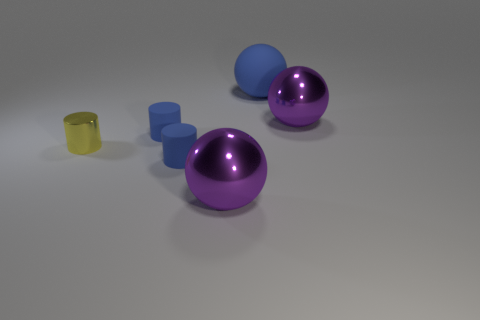Are there any tiny metal cylinders that are behind the large rubber ball to the right of the small thing in front of the tiny metallic object?
Ensure brevity in your answer.  No. The yellow object is what shape?
Ensure brevity in your answer.  Cylinder. Is the number of objects to the right of the metallic cylinder less than the number of shiny cylinders?
Provide a short and direct response. No. Is there a big purple metal thing that has the same shape as the tiny metallic thing?
Provide a succinct answer. No. What number of things are small metallic things or things?
Give a very brief answer. 6. Is there a big purple metallic object?
Provide a succinct answer. Yes. Is the number of objects less than the number of matte cylinders?
Give a very brief answer. No. Are there any gray matte spheres that have the same size as the yellow metallic cylinder?
Your answer should be very brief. No. There is a yellow metal object; does it have the same shape as the purple thing that is to the right of the big blue rubber object?
Provide a short and direct response. No. How many cylinders are either big matte objects or yellow shiny things?
Give a very brief answer. 1. 